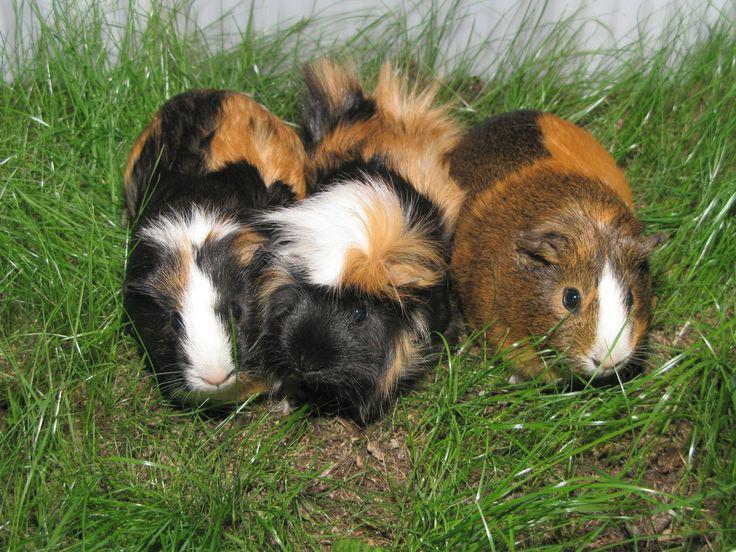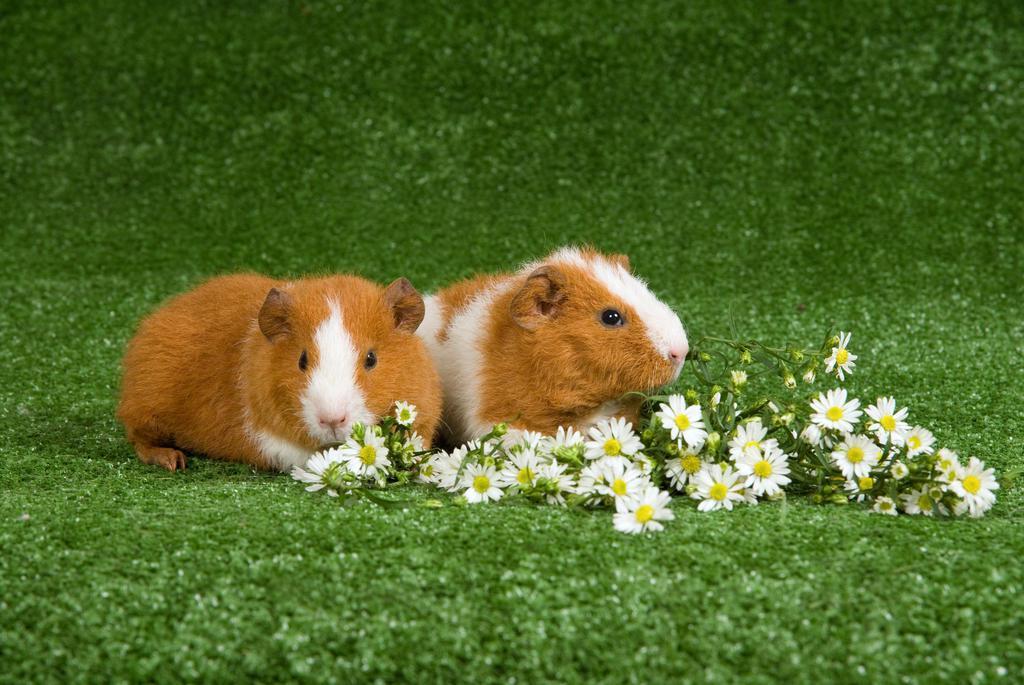The first image is the image on the left, the second image is the image on the right. For the images displayed, is the sentence "Each image shows exactly one side-by-side pair of guinea pigs posed outdoors on green ground." factually correct? Answer yes or no. No. 